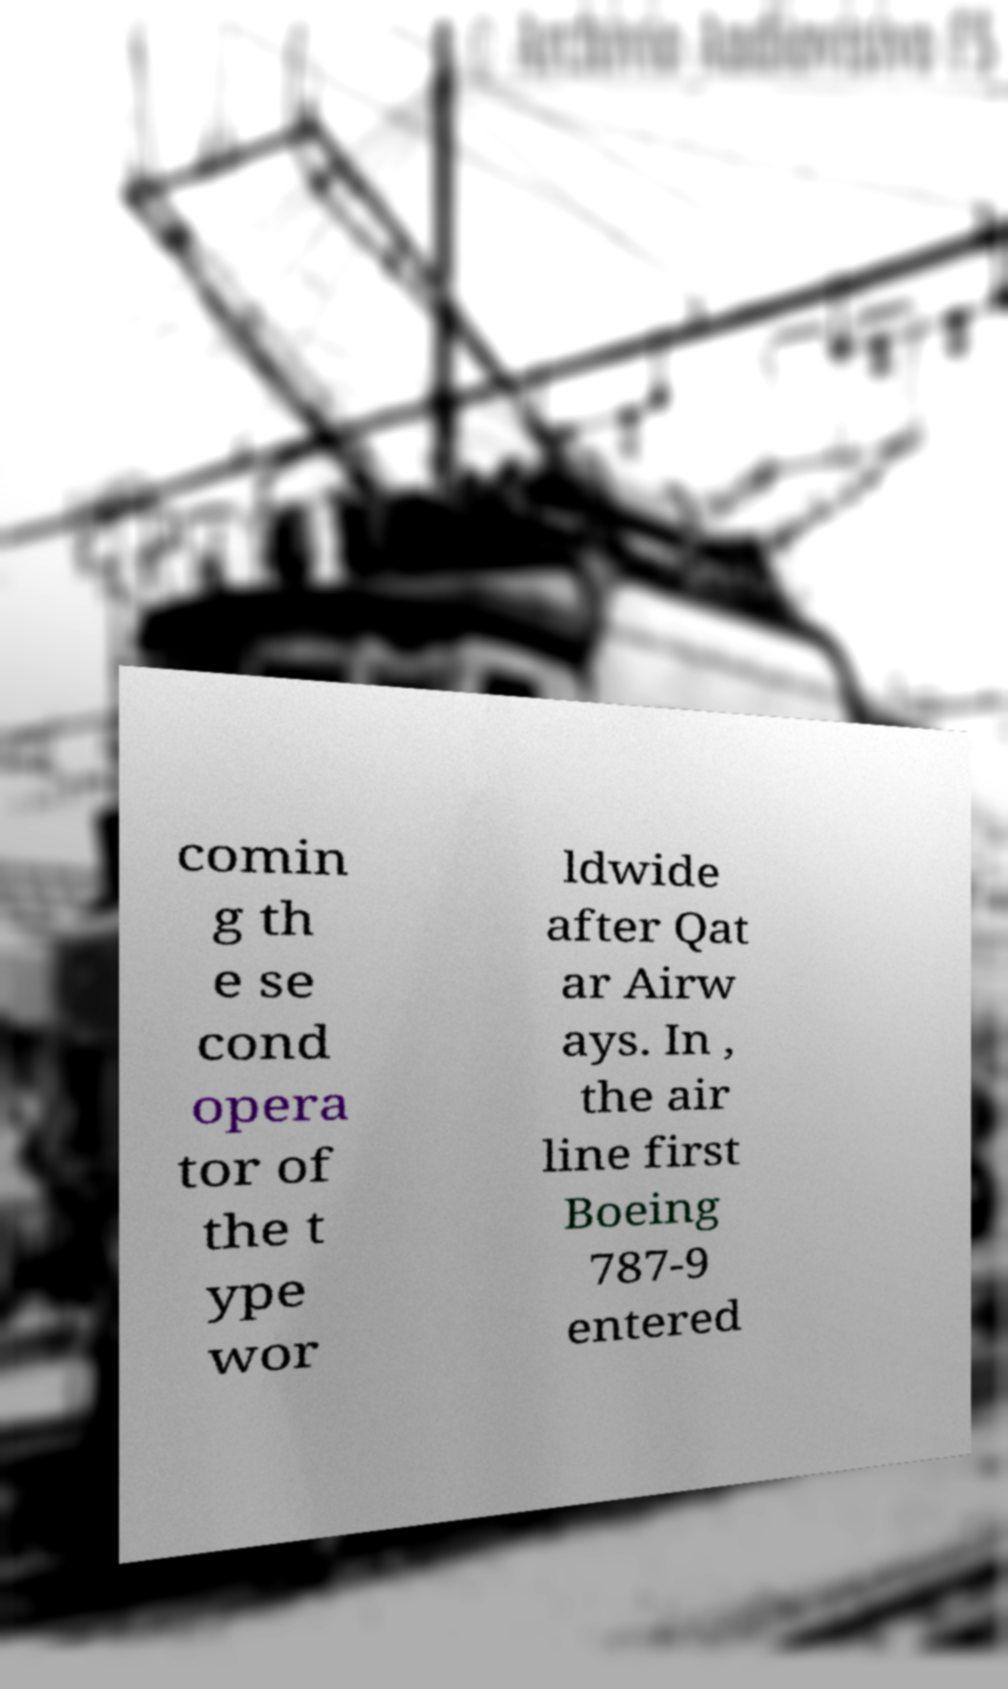Could you extract and type out the text from this image? comin g th e se cond opera tor of the t ype wor ldwide after Qat ar Airw ays. In , the air line first Boeing 787-9 entered 